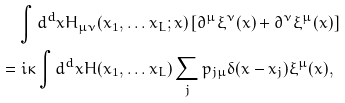Convert formula to latex. <formula><loc_0><loc_0><loc_500><loc_500>& \quad \int d ^ { d } x H _ { \mu \nu } ( x _ { 1 } , \dots x _ { L } ; x ) \left [ \partial ^ { \mu } \xi ^ { \nu } ( x ) + \partial ^ { \nu } \xi ^ { \mu } ( x ) \right ] \\ & = i \kappa \int d ^ { d } x H ( x _ { 1 } , \dots x _ { L } ) \sum _ { j } p _ { j \mu } \delta ( x - x _ { j } ) \xi ^ { \mu } ( x ) ,</formula> 